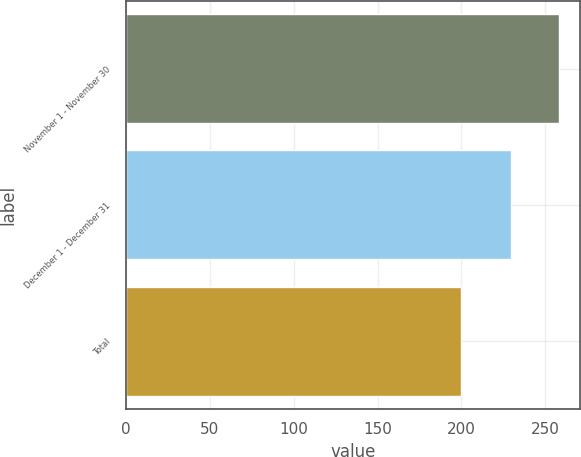<chart> <loc_0><loc_0><loc_500><loc_500><bar_chart><fcel>November 1 - November 30<fcel>December 1 - December 31<fcel>Total<nl><fcel>257.93<fcel>229.67<fcel>199.58<nl></chart> 